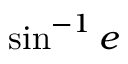Convert formula to latex. <formula><loc_0><loc_0><loc_500><loc_500>\sin ^ { - 1 } e</formula> 